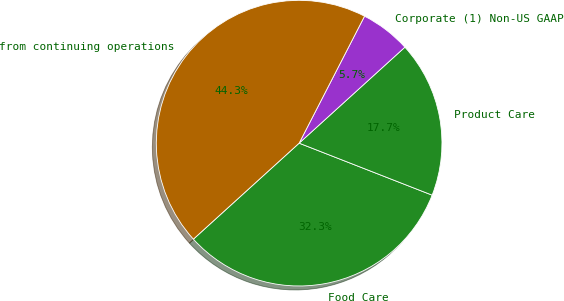Convert chart to OTSL. <chart><loc_0><loc_0><loc_500><loc_500><pie_chart><fcel>Food Care<fcel>Product Care<fcel>Corporate (1) Non-US GAAP<fcel>from continuing operations<nl><fcel>32.34%<fcel>17.66%<fcel>5.7%<fcel>44.3%<nl></chart> 